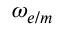Convert formula to latex. <formula><loc_0><loc_0><loc_500><loc_500>\omega _ { e / m }</formula> 